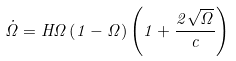Convert formula to latex. <formula><loc_0><loc_0><loc_500><loc_500>\dot { \Omega } = H \Omega \left ( 1 - \Omega \right ) \left ( 1 + \frac { 2 \sqrt { \Omega } } { c } \right )</formula> 